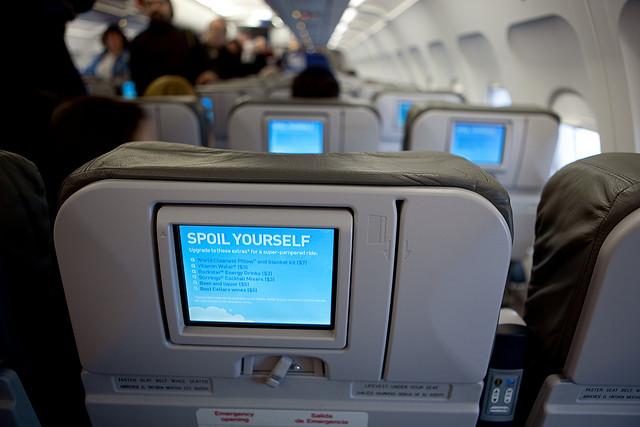Can this small screen play full movies?
Write a very short answer. Yes. Was this photo taken on a bus?
Give a very brief answer. No. Is the fasten seatbelt sign on right now?
Short answer required. No. What is the monitor used for?
Give a very brief answer. Entertainment. What room was this taken in?
Give a very brief answer. Airplane. 